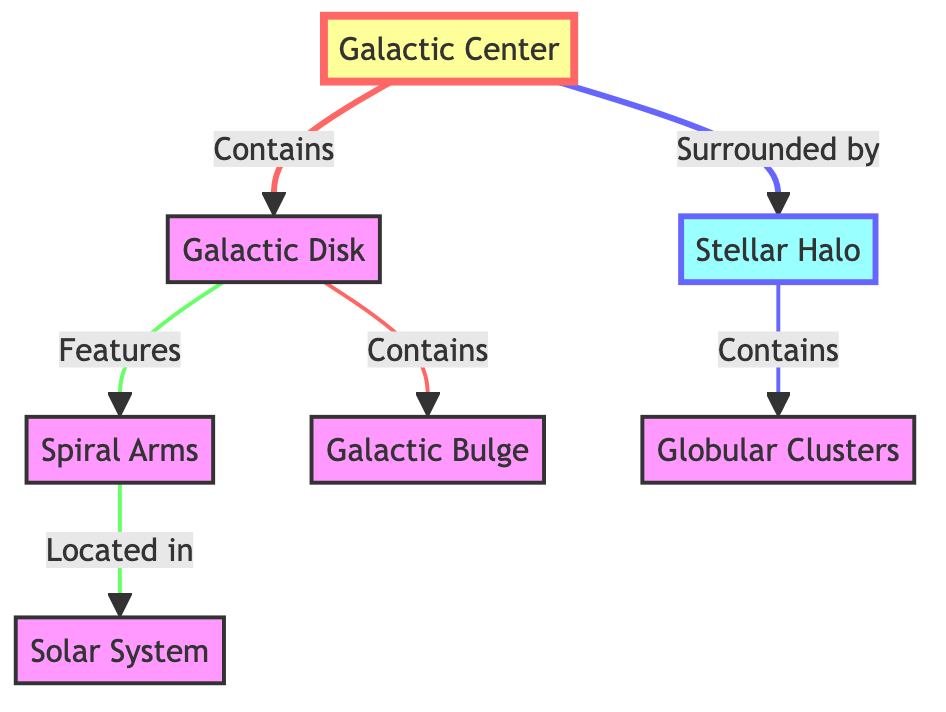What is located at the center of the diagram? The diagram specifically identifies the "Galactic Center" as the node at the central position. This is directly stated in the diagram as it is positioned at the very center, symbolizing the core of the Milky Way Galaxy.
Answer: Galactic Center How many primary components are there in the Milky Way Galaxy according to the diagram? By analyzing the diagram, the distinct nodes representing primary components include the Galactic Center, Galactic Disk, Stellar Halo, Galacic Bulge, and the Solar System, totaling five main components.
Answer: 5 Which component contains the Globular Clusters? The diagram indicates that the "Stellar Halo" is the component that contains the "Globular Clusters," as shown by the directional arrow leading from Stellar Halo to Globular Clusters.
Answer: Stellar Halo What do the Spiral Arms feature? The diagram shows that the "Galactic Disk" features the "Spiral Arms," providing a direct link that denotes this relationship clearly in the flow of the diagram.
Answer: Spiral Arms What surrounds the Galactic Center? The diagram explicitly states that the "Stellar Halo" surrounds the "Galactic Center," as indicated by the directional connection stemming from the Galactic Center towards the Stellar Halo.
Answer: Stellar Halo Which part of the Galaxy is the location of the Solar System? According to the diagram, the "Solar System" is located within the "Spiral Arms," making this the specific area where the Solar System is situated, as stated through the connection line.
Answer: Spiral Arms What is directly connected to the Galactic Disk? The diagram shows that the "Galactic Bulge" is directly connected to the "Galactic Disk," indicating that the Galactic Bulge is contained within or part of the Galactic Disk structure.
Answer: Galactic Bulge How do Globular Clusters relate to the Stellar Halo? The diagram illustrates a direct connection where the "Stellar Halo" contains the "Globular Clusters," indicating that all globular clusters are found within this halo structure.
Answer: Contains In which direction does the Galactic Bulge extend from? The diagram shows that the "Galactic Bulge" is a part of the "Galactic Disk," which indicates its spatial relationship and direction of extension from the disk.
Answer: Galactic Disk 